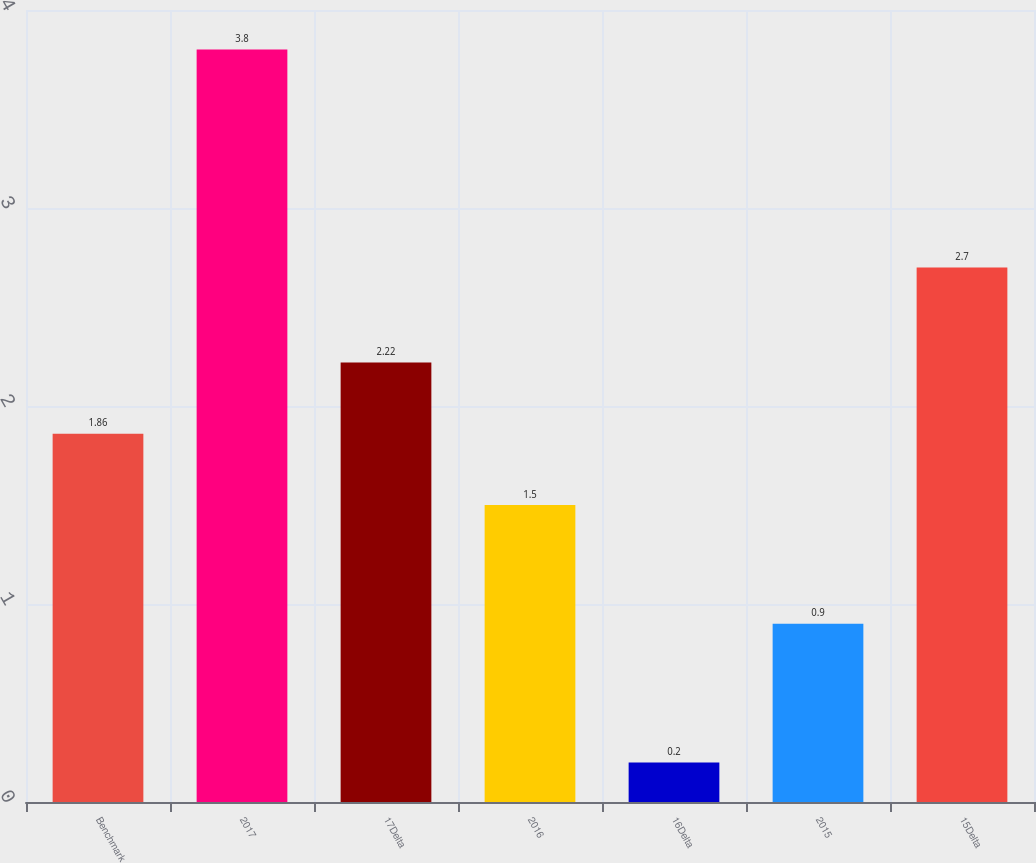<chart> <loc_0><loc_0><loc_500><loc_500><bar_chart><fcel>Benchmark<fcel>2017<fcel>17Delta<fcel>2016<fcel>16Delta<fcel>2015<fcel>15Delta<nl><fcel>1.86<fcel>3.8<fcel>2.22<fcel>1.5<fcel>0.2<fcel>0.9<fcel>2.7<nl></chart> 